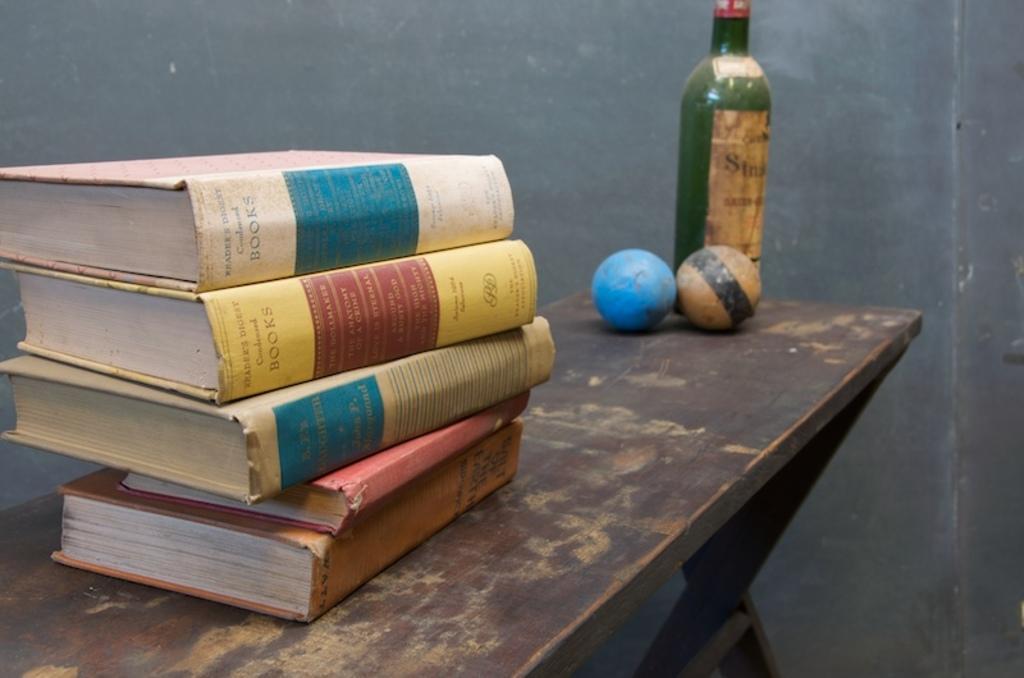Could you give a brief overview of what you see in this image? In this image i can see few books, two balls, a bottle on a table at the back ground there is a wall. 